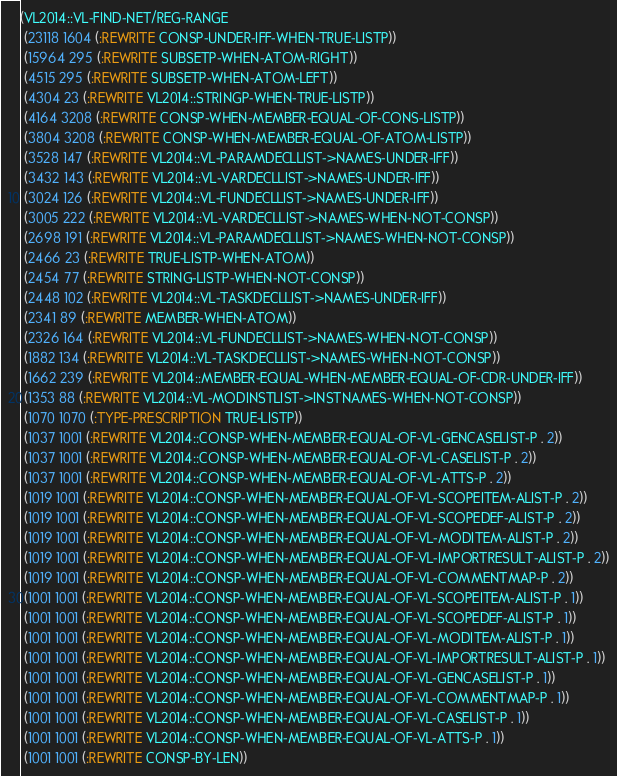<code> <loc_0><loc_0><loc_500><loc_500><_Lisp_>(VL2014::VL-FIND-NET/REG-RANGE
 (23118 1604 (:REWRITE CONSP-UNDER-IFF-WHEN-TRUE-LISTP))
 (15964 295 (:REWRITE SUBSETP-WHEN-ATOM-RIGHT))
 (4515 295 (:REWRITE SUBSETP-WHEN-ATOM-LEFT))
 (4304 23 (:REWRITE VL2014::STRINGP-WHEN-TRUE-LISTP))
 (4164 3208 (:REWRITE CONSP-WHEN-MEMBER-EQUAL-OF-CONS-LISTP))
 (3804 3208 (:REWRITE CONSP-WHEN-MEMBER-EQUAL-OF-ATOM-LISTP))
 (3528 147 (:REWRITE VL2014::VL-PARAMDECLLIST->NAMES-UNDER-IFF))
 (3432 143 (:REWRITE VL2014::VL-VARDECLLIST->NAMES-UNDER-IFF))
 (3024 126 (:REWRITE VL2014::VL-FUNDECLLIST->NAMES-UNDER-IFF))
 (3005 222 (:REWRITE VL2014::VL-VARDECLLIST->NAMES-WHEN-NOT-CONSP))
 (2698 191 (:REWRITE VL2014::VL-PARAMDECLLIST->NAMES-WHEN-NOT-CONSP))
 (2466 23 (:REWRITE TRUE-LISTP-WHEN-ATOM))
 (2454 77 (:REWRITE STRING-LISTP-WHEN-NOT-CONSP))
 (2448 102 (:REWRITE VL2014::VL-TASKDECLLIST->NAMES-UNDER-IFF))
 (2341 89 (:REWRITE MEMBER-WHEN-ATOM))
 (2326 164 (:REWRITE VL2014::VL-FUNDECLLIST->NAMES-WHEN-NOT-CONSP))
 (1882 134 (:REWRITE VL2014::VL-TASKDECLLIST->NAMES-WHEN-NOT-CONSP))
 (1662 239 (:REWRITE VL2014::MEMBER-EQUAL-WHEN-MEMBER-EQUAL-OF-CDR-UNDER-IFF))
 (1353 88 (:REWRITE VL2014::VL-MODINSTLIST->INSTNAMES-WHEN-NOT-CONSP))
 (1070 1070 (:TYPE-PRESCRIPTION TRUE-LISTP))
 (1037 1001 (:REWRITE VL2014::CONSP-WHEN-MEMBER-EQUAL-OF-VL-GENCASELIST-P . 2))
 (1037 1001 (:REWRITE VL2014::CONSP-WHEN-MEMBER-EQUAL-OF-VL-CASELIST-P . 2))
 (1037 1001 (:REWRITE VL2014::CONSP-WHEN-MEMBER-EQUAL-OF-VL-ATTS-P . 2))
 (1019 1001 (:REWRITE VL2014::CONSP-WHEN-MEMBER-EQUAL-OF-VL-SCOPEITEM-ALIST-P . 2))
 (1019 1001 (:REWRITE VL2014::CONSP-WHEN-MEMBER-EQUAL-OF-VL-SCOPEDEF-ALIST-P . 2))
 (1019 1001 (:REWRITE VL2014::CONSP-WHEN-MEMBER-EQUAL-OF-VL-MODITEM-ALIST-P . 2))
 (1019 1001 (:REWRITE VL2014::CONSP-WHEN-MEMBER-EQUAL-OF-VL-IMPORTRESULT-ALIST-P . 2))
 (1019 1001 (:REWRITE VL2014::CONSP-WHEN-MEMBER-EQUAL-OF-VL-COMMENTMAP-P . 2))
 (1001 1001 (:REWRITE VL2014::CONSP-WHEN-MEMBER-EQUAL-OF-VL-SCOPEITEM-ALIST-P . 1))
 (1001 1001 (:REWRITE VL2014::CONSP-WHEN-MEMBER-EQUAL-OF-VL-SCOPEDEF-ALIST-P . 1))
 (1001 1001 (:REWRITE VL2014::CONSP-WHEN-MEMBER-EQUAL-OF-VL-MODITEM-ALIST-P . 1))
 (1001 1001 (:REWRITE VL2014::CONSP-WHEN-MEMBER-EQUAL-OF-VL-IMPORTRESULT-ALIST-P . 1))
 (1001 1001 (:REWRITE VL2014::CONSP-WHEN-MEMBER-EQUAL-OF-VL-GENCASELIST-P . 1))
 (1001 1001 (:REWRITE VL2014::CONSP-WHEN-MEMBER-EQUAL-OF-VL-COMMENTMAP-P . 1))
 (1001 1001 (:REWRITE VL2014::CONSP-WHEN-MEMBER-EQUAL-OF-VL-CASELIST-P . 1))
 (1001 1001 (:REWRITE VL2014::CONSP-WHEN-MEMBER-EQUAL-OF-VL-ATTS-P . 1))
 (1001 1001 (:REWRITE CONSP-BY-LEN))</code> 